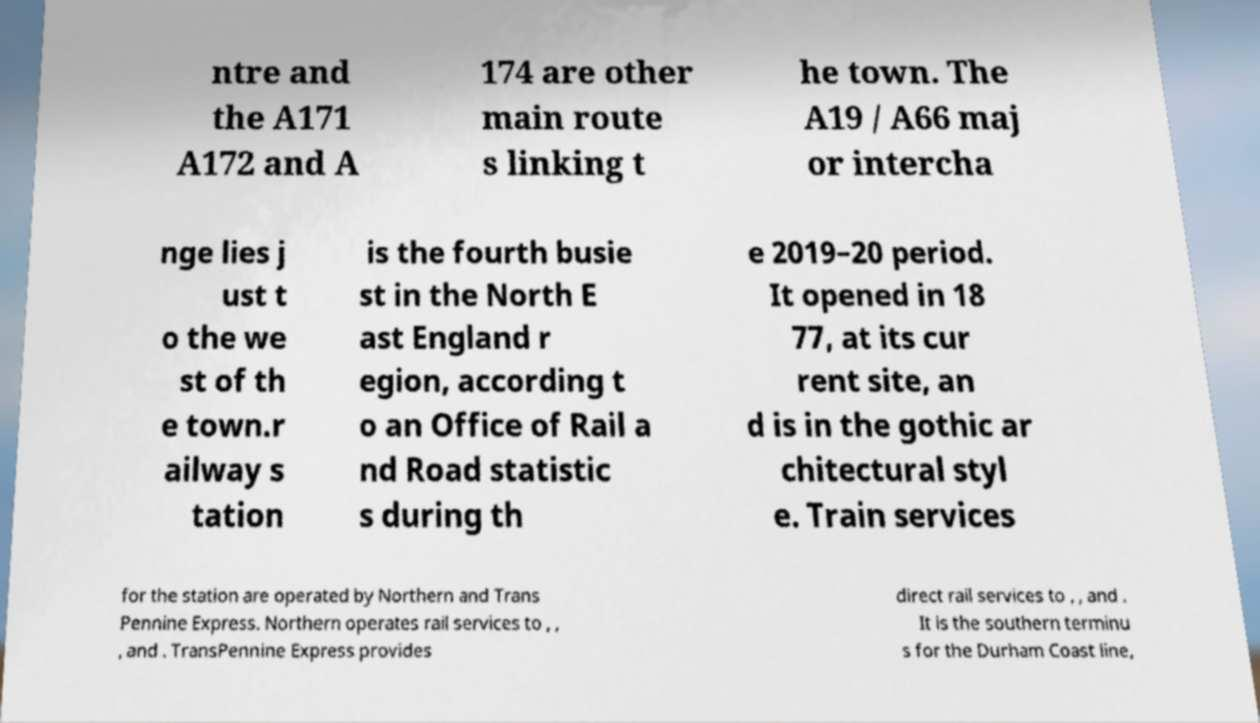There's text embedded in this image that I need extracted. Can you transcribe it verbatim? ntre and the A171 A172 and A 174 are other main route s linking t he town. The A19 / A66 maj or intercha nge lies j ust t o the we st of th e town.r ailway s tation is the fourth busie st in the North E ast England r egion, according t o an Office of Rail a nd Road statistic s during th e 2019–20 period. It opened in 18 77, at its cur rent site, an d is in the gothic ar chitectural styl e. Train services for the station are operated by Northern and Trans Pennine Express. Northern operates rail services to , , , and . TransPennine Express provides direct rail services to , , and . It is the southern terminu s for the Durham Coast line, 